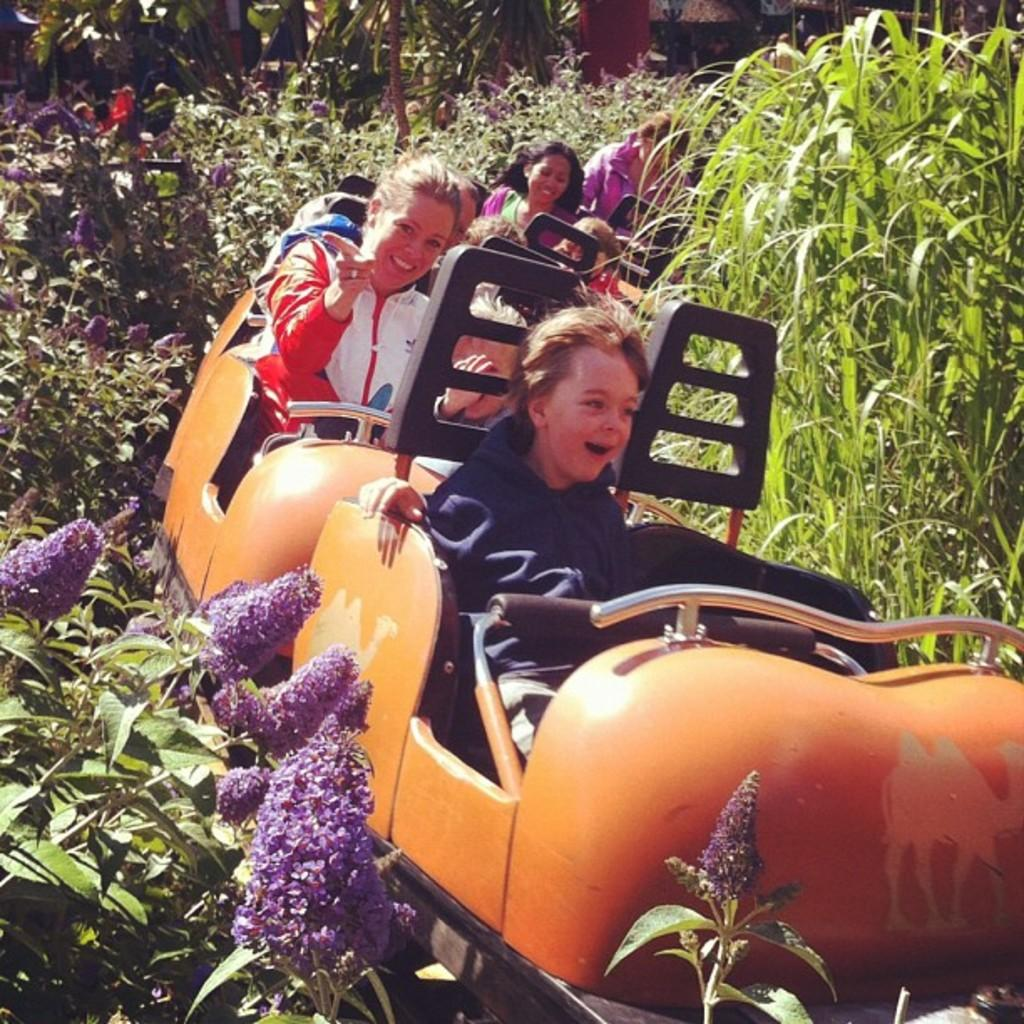What is happening with the group of people in the image? The people in the image are sitting and smiling. What are they doing while sitting and smiling? They are on a ride. What type of vegetation can be seen in the image? There are plants, flowers, and trees in the image. Can you tell me how many tomatoes are visible in the image? There are no tomatoes present in the image. What part of the body is the elbow of the person sitting on the left? There is no specific person or elbow mentioned in the image, so it is not possible to answer that question. 